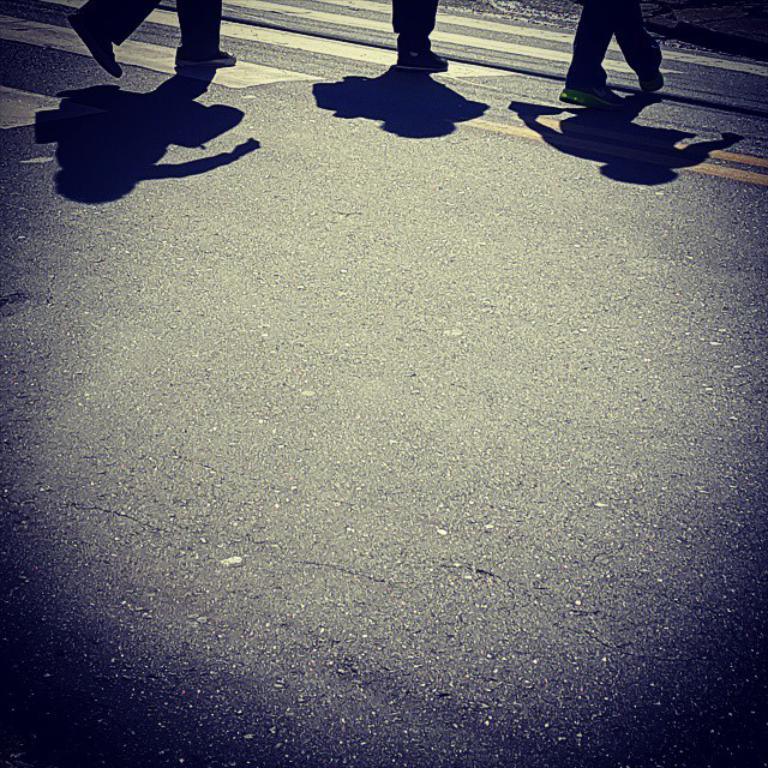Please provide a concise description of this image. Here we can see legs and shadows of three persons. This is a road. 